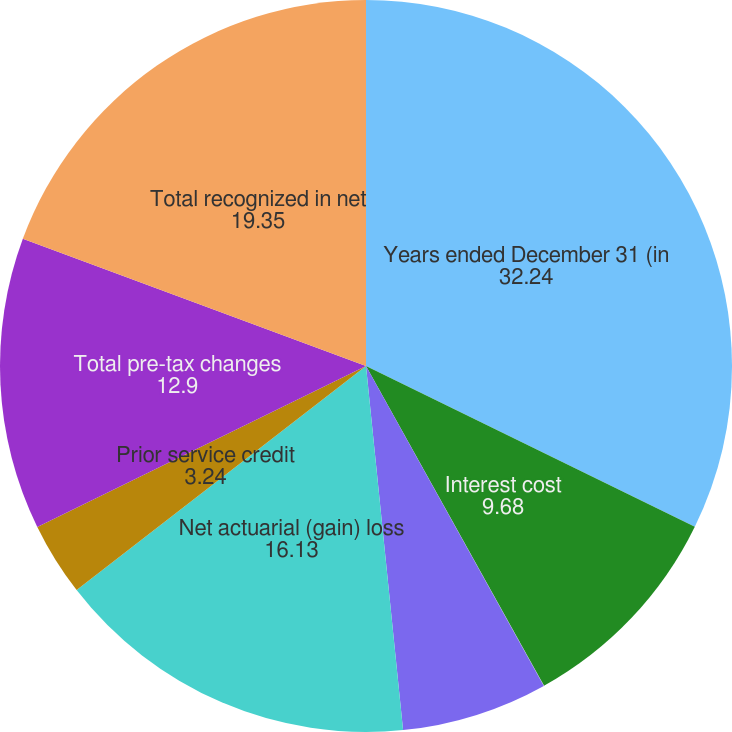Convert chart to OTSL. <chart><loc_0><loc_0><loc_500><loc_500><pie_chart><fcel>Years ended December 31 (in<fcel>Interest cost<fcel>Recognized prior service<fcel>Net periodic benefit (income)<fcel>Net actuarial (gain) loss<fcel>Prior service credit<fcel>Total pre-tax changes<fcel>Total recognized in net<nl><fcel>32.24%<fcel>9.68%<fcel>0.01%<fcel>6.46%<fcel>16.13%<fcel>3.24%<fcel>12.9%<fcel>19.35%<nl></chart> 